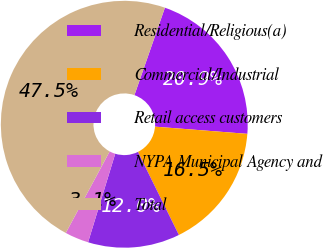Convert chart. <chart><loc_0><loc_0><loc_500><loc_500><pie_chart><fcel>Residential/Religious(a)<fcel>Commercial/Industrial<fcel>Retail access customers<fcel>NYPA Municipal Agency and<fcel>Total<nl><fcel>20.9%<fcel>16.47%<fcel>12.03%<fcel>3.12%<fcel>47.48%<nl></chart> 